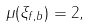<formula> <loc_0><loc_0><loc_500><loc_500>\mu ( \xi _ { f , b } ) = 2 ,</formula> 